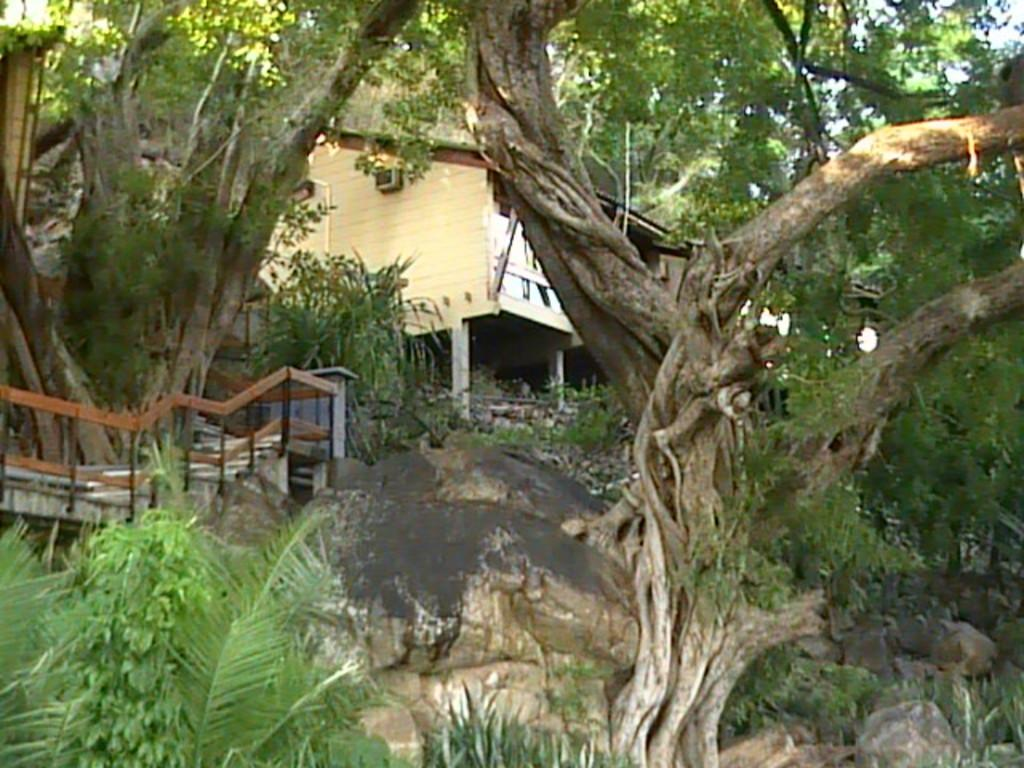What type of house is in the center of the image? There is a wooden house in the center of the image. What natural elements can be seen in the image? There are trees and rocks in the image. Can you describe any other objects in the image? There are some unspecified objects in the image. What type of creature is interacting with the account in the image? There is no creature or account present in the image. 